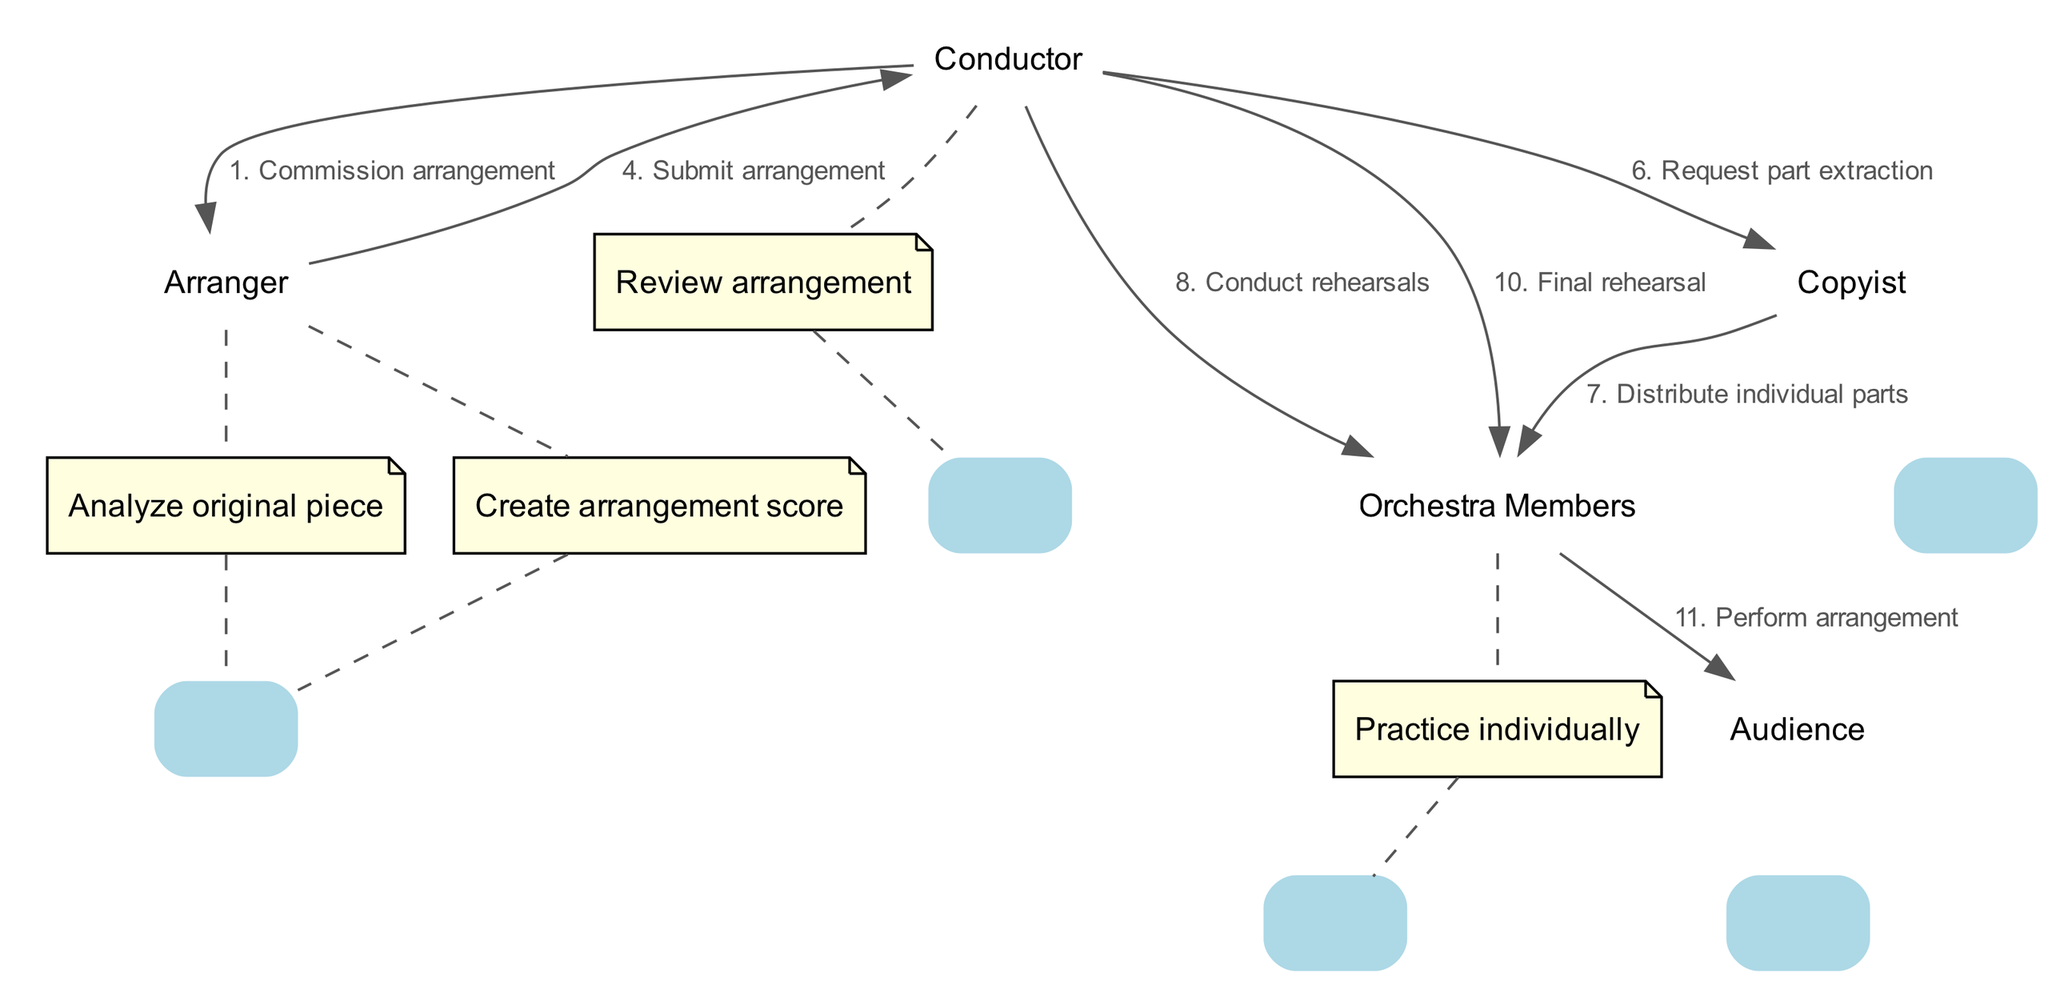What is the first action in the sequence? The first action in the sequence is initiated by the Conductor, who commissions the arrangement from the Arranger. The sequence shows the flow starting with the Conductor's action.
Answer: Commission arrangement How many actors are in the sequence diagram? There are five actors involved in the sequence, which are the Conductor, Arranger, Orchestra Members, Copyist, and Audience. Each actor independently carries out actions in the process.
Answer: Five Who receives the request for part extraction? The request for part extraction is made by the Conductor to the Copyist. This action connects the Conductor directly to the Copyist's role in preparing the music for the orchestra members.
Answer: Copyist What action is taken after the arrangement is submitted? After the arrangement is submitted, the Conductor reviews the arrangement. This action indicates the decision-making phase following the completion of the arrangement.
Answer: Review arrangement How many actions does the Arranger perform in total? The Arranger performs three distinct actions in total: analyzing the original piece, creating the arrangement score, and submitting the arrangement. These actions are sequentially listed under the Arranger's responsibilities.
Answer: Three What is the final action in the sequence diagram? The final action in the sequence is the performance of the arrangement by the Orchestra Members to the Audience. This signifies the culmination of all prior steps in the diagram.
Answer: Perform arrangement Which actor distributes individual parts to the Orchestra Members? The Copyist distributes individual parts to the Orchestra Members. This step shows the role of the Copyist in ensuring that each musician has their respective part for practice and rehearsal.
Answer: Copyist What action occurs immediately before the final rehearsal? Immediately before the final rehearsal, the Conductor conducts the rehearsals with the Orchestra Members. This action signifies the preparation leading up to the last steps before the performance.
Answer: Conduct rehearsals 